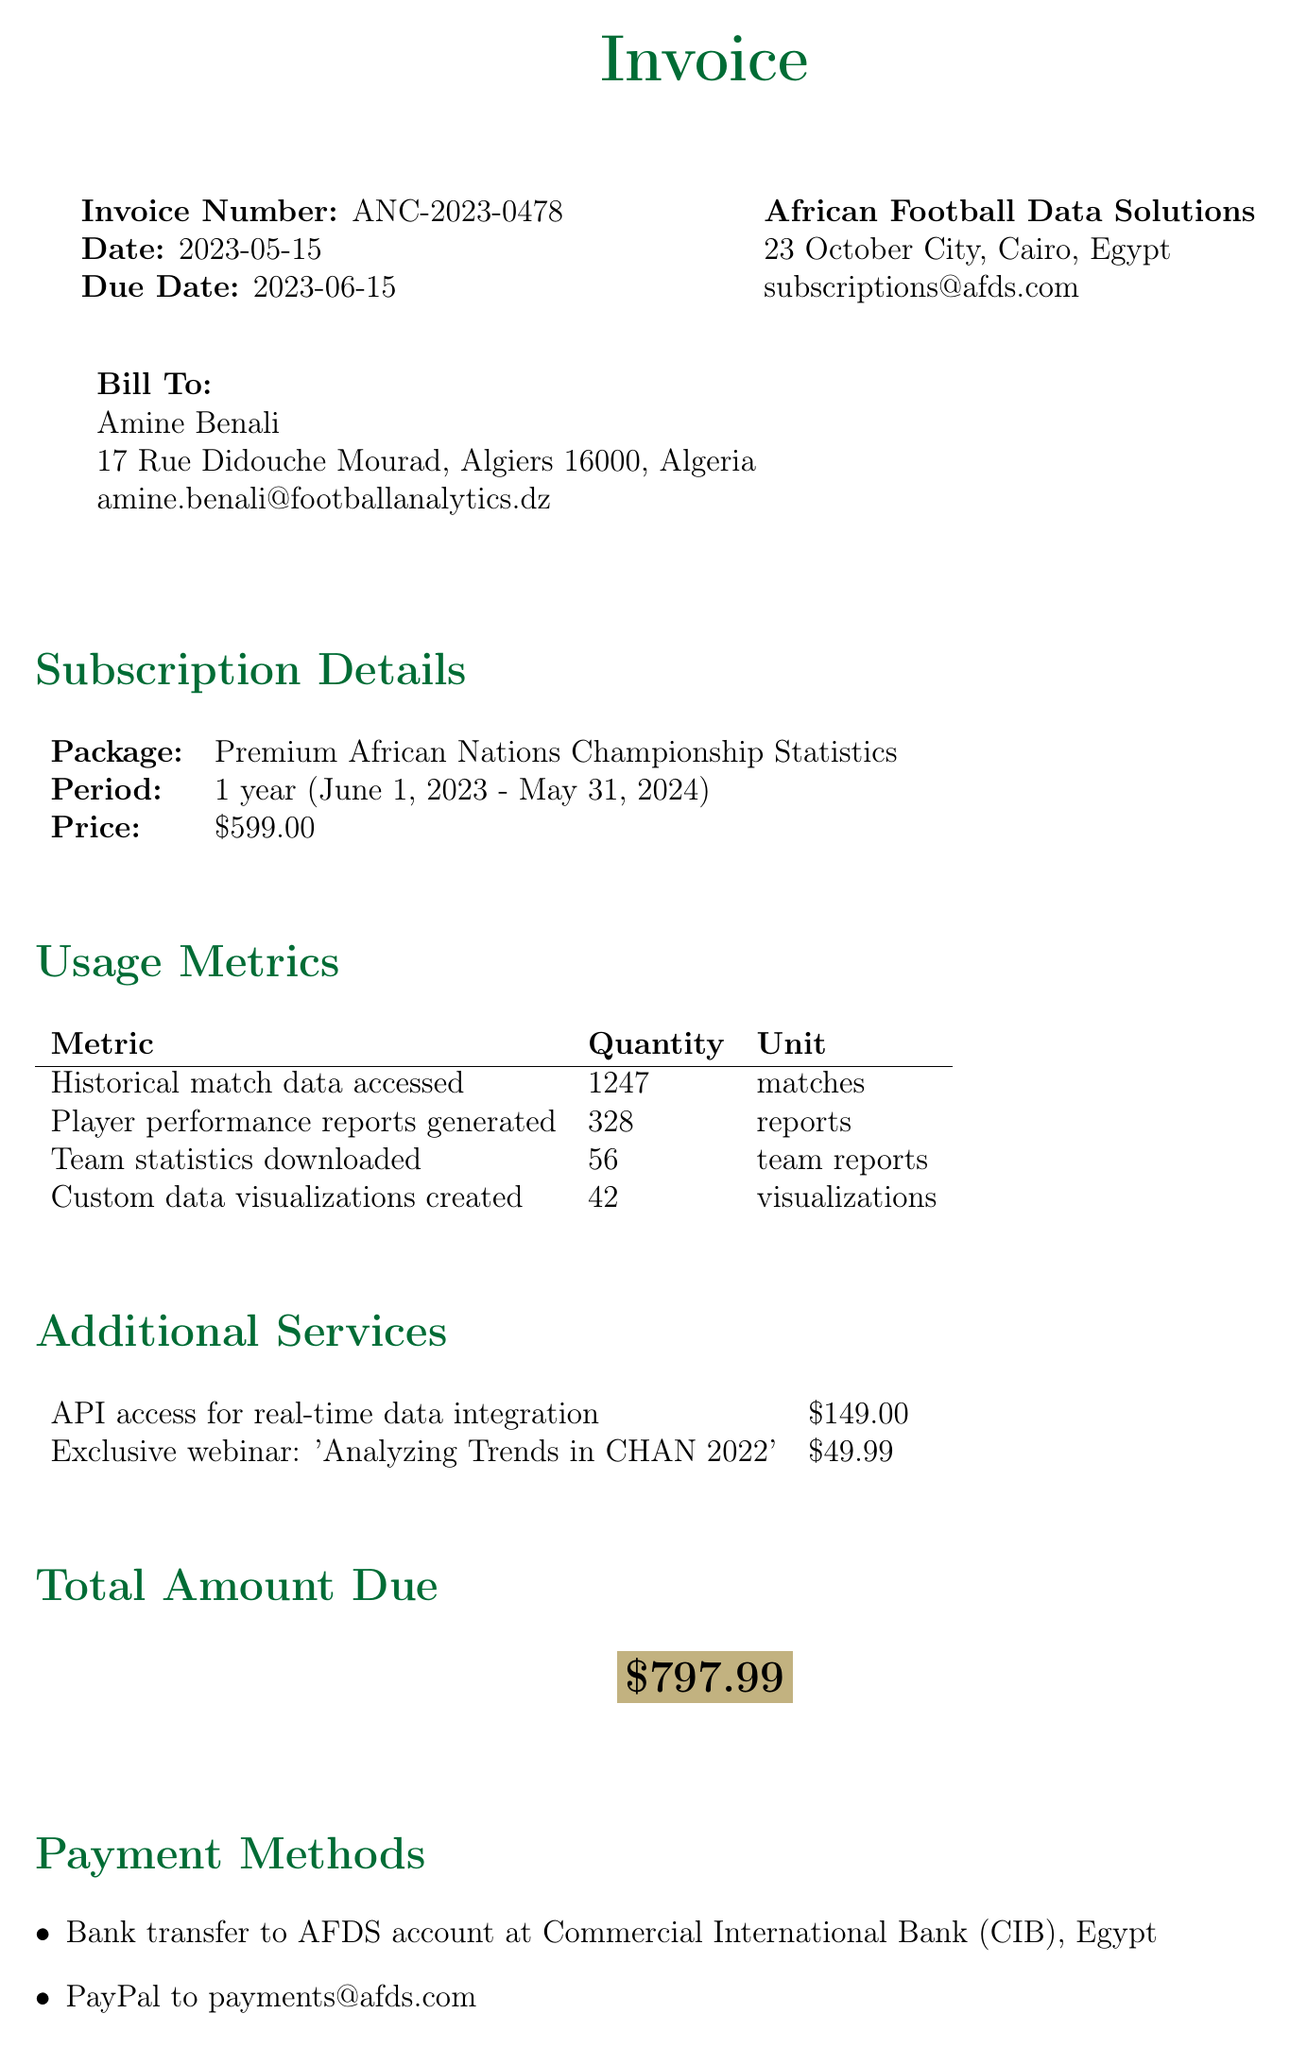What is the invoice number? The invoice number is specified in the document as the identifier for the transaction.
Answer: ANC-2023-0478 What is the total amount due? The total amount due is the cumulative cost for the subscription and any additional services rendered.
Answer: $797.99 Who is the client? The client information includes the name of the individual billed for the subscription.
Answer: Amine Benali What is the subscription package? The subscription package refers to the specific service purchased by the client for statistical data.
Answer: Premium African Nations Championship Statistics How many historical match data were accessed? This quantity refers to the specific metric related to the client's usage of historical match data.
Answer: 1247 What date is the invoice due? The due date indicates the deadline by which the payment must be completed.
Answer: 2023-06-15 What additional service has a price of $49.99? This question targets the specific service offered that is associated with the stated price.
Answer: Exclusive webinar: 'Analyzing Trends in CHAN 2022' What is the payment method for PayPal? This question seeks the specific email address provided for PayPal payments.
Answer: payments@afds.com What discount is offered for Algerian customers on renewal? This question pertains to the promotional offer listed in the special notes for future subscriptions.
Answer: 10% discount 